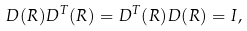Convert formula to latex. <formula><loc_0><loc_0><loc_500><loc_500>D ( R ) D ^ { T } ( R ) = D ^ { T } ( R ) D ( R ) = I ,</formula> 